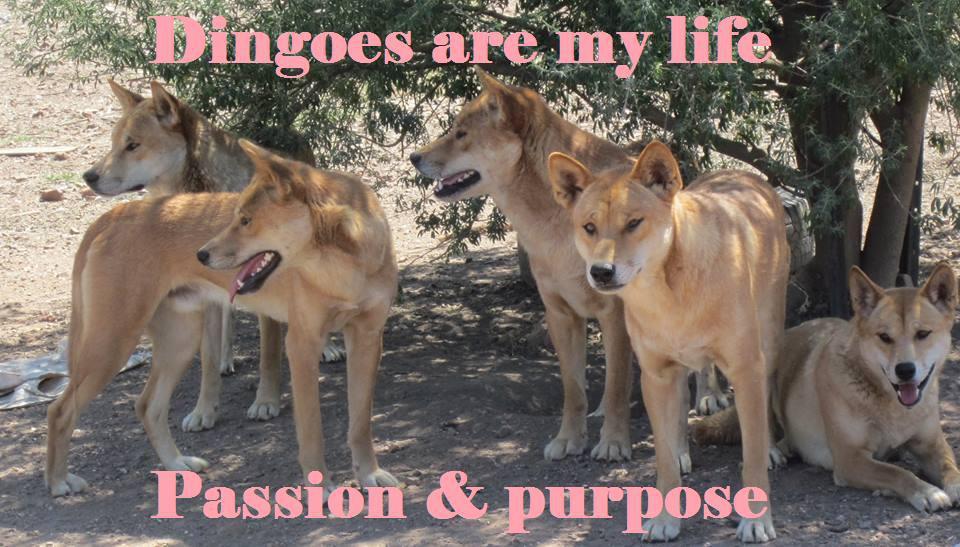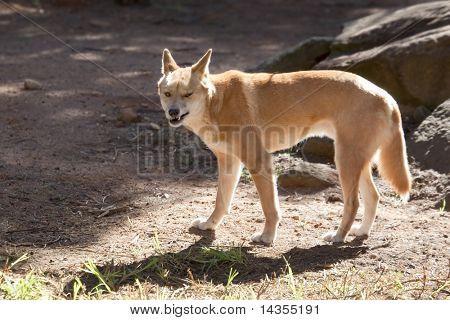The first image is the image on the left, the second image is the image on the right. Evaluate the accuracy of this statement regarding the images: "Each image shows a single dingo standing on all fours, and the dingo on the right has its body turned leftward.". Is it true? Answer yes or no. No. The first image is the image on the left, the second image is the image on the right. For the images shown, is this caption "A dingo is surrounded by a grass and flowered ground cover" true? Answer yes or no. No. 